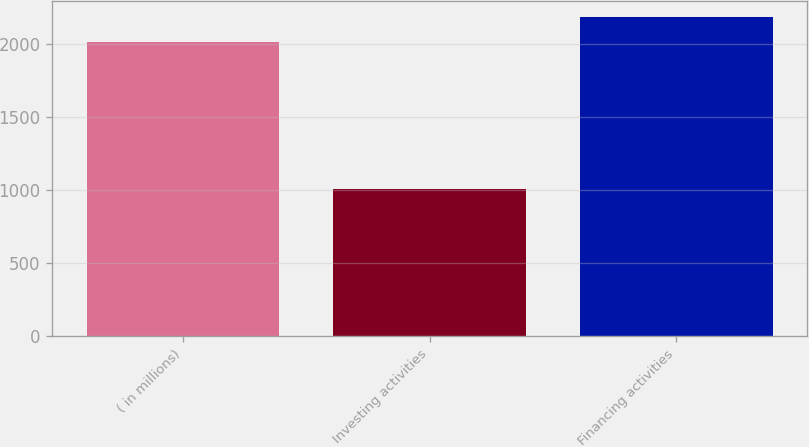Convert chart to OTSL. <chart><loc_0><loc_0><loc_500><loc_500><bar_chart><fcel>( in millions)<fcel>Investing activities<fcel>Financing activities<nl><fcel>2008<fcel>1003<fcel>2179<nl></chart> 